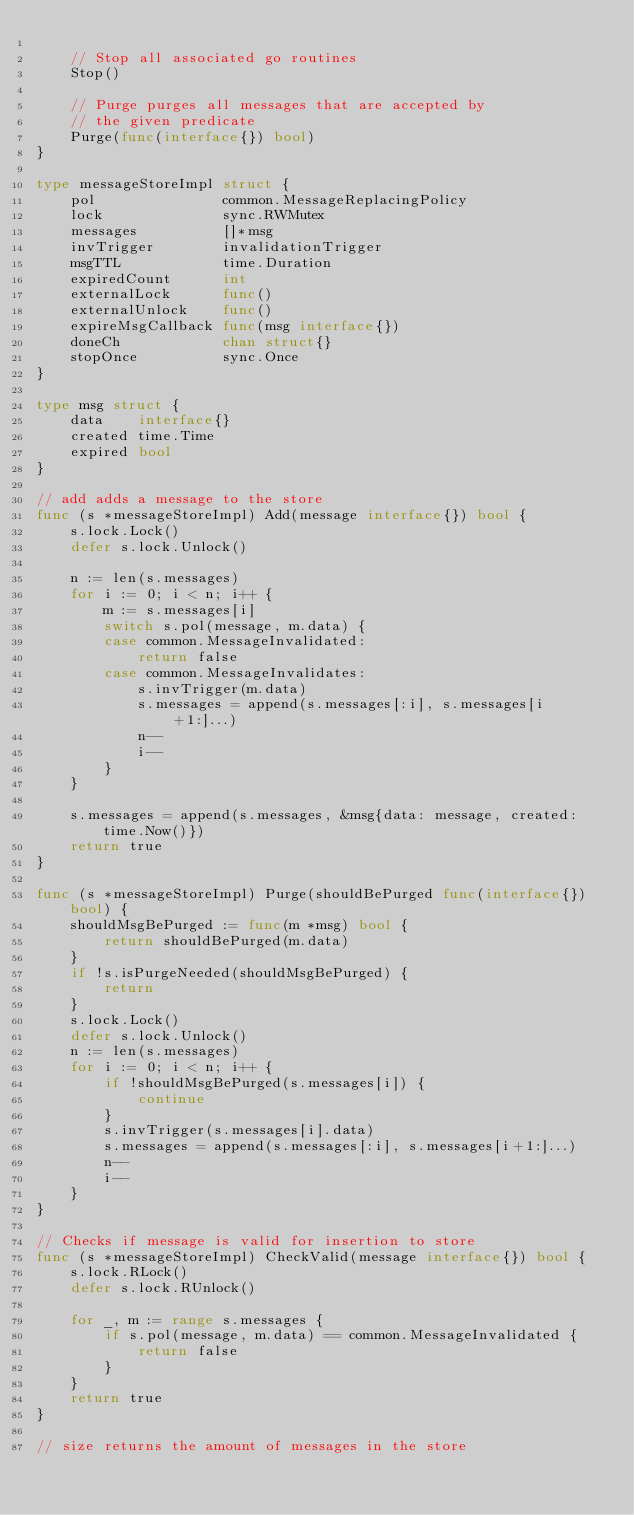Convert code to text. <code><loc_0><loc_0><loc_500><loc_500><_Go_>
	// Stop all associated go routines
	Stop()

	// Purge purges all messages that are accepted by
	// the given predicate
	Purge(func(interface{}) bool)
}

type messageStoreImpl struct {
	pol               common.MessageReplacingPolicy
	lock              sync.RWMutex
	messages          []*msg
	invTrigger        invalidationTrigger
	msgTTL            time.Duration
	expiredCount      int
	externalLock      func()
	externalUnlock    func()
	expireMsgCallback func(msg interface{})
	doneCh            chan struct{}
	stopOnce          sync.Once
}

type msg struct {
	data    interface{}
	created time.Time
	expired bool
}

// add adds a message to the store
func (s *messageStoreImpl) Add(message interface{}) bool {
	s.lock.Lock()
	defer s.lock.Unlock()

	n := len(s.messages)
	for i := 0; i < n; i++ {
		m := s.messages[i]
		switch s.pol(message, m.data) {
		case common.MessageInvalidated:
			return false
		case common.MessageInvalidates:
			s.invTrigger(m.data)
			s.messages = append(s.messages[:i], s.messages[i+1:]...)
			n--
			i--
		}
	}

	s.messages = append(s.messages, &msg{data: message, created: time.Now()})
	return true
}

func (s *messageStoreImpl) Purge(shouldBePurged func(interface{}) bool) {
	shouldMsgBePurged := func(m *msg) bool {
		return shouldBePurged(m.data)
	}
	if !s.isPurgeNeeded(shouldMsgBePurged) {
		return
	}
	s.lock.Lock()
	defer s.lock.Unlock()
	n := len(s.messages)
	for i := 0; i < n; i++ {
		if !shouldMsgBePurged(s.messages[i]) {
			continue
		}
		s.invTrigger(s.messages[i].data)
		s.messages = append(s.messages[:i], s.messages[i+1:]...)
		n--
		i--
	}
}

// Checks if message is valid for insertion to store
func (s *messageStoreImpl) CheckValid(message interface{}) bool {
	s.lock.RLock()
	defer s.lock.RUnlock()

	for _, m := range s.messages {
		if s.pol(message, m.data) == common.MessageInvalidated {
			return false
		}
	}
	return true
}

// size returns the amount of messages in the store</code> 